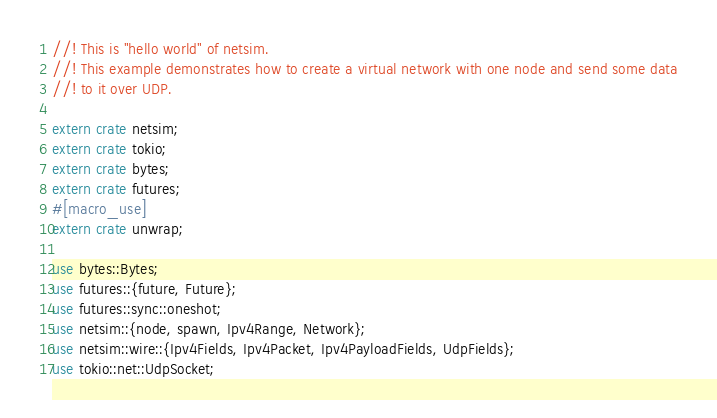<code> <loc_0><loc_0><loc_500><loc_500><_Rust_>//! This is "hello world" of netsim.
//! This example demonstrates how to create a virtual network with one node and send some data
//! to it over UDP.

extern crate netsim;
extern crate tokio;
extern crate bytes;
extern crate futures;
#[macro_use]
extern crate unwrap;

use bytes::Bytes;
use futures::{future, Future};
use futures::sync::oneshot;
use netsim::{node, spawn, Ipv4Range, Network};
use netsim::wire::{Ipv4Fields, Ipv4Packet, Ipv4PayloadFields, UdpFields};
use tokio::net::UdpSocket;
</code> 